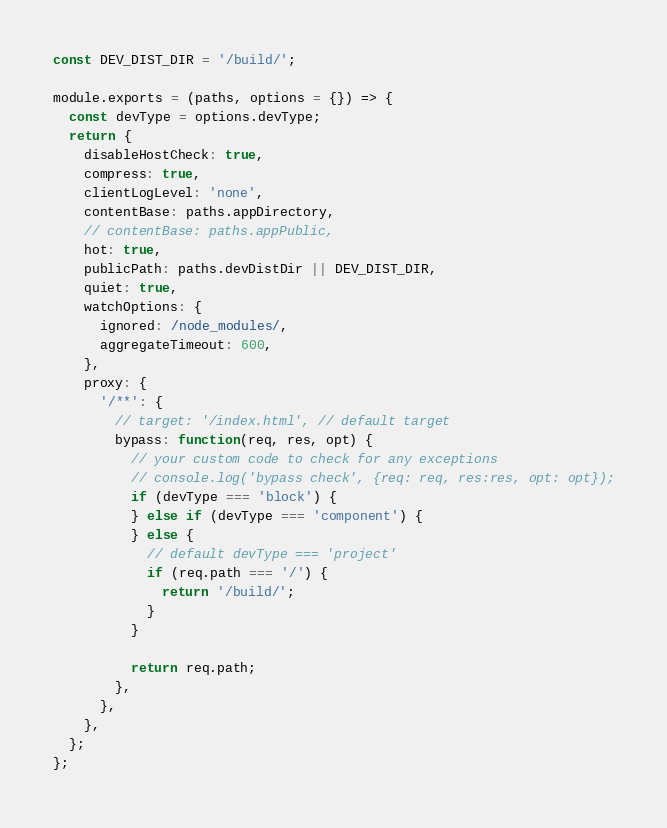<code> <loc_0><loc_0><loc_500><loc_500><_JavaScript_>const DEV_DIST_DIR = '/build/';

module.exports = (paths, options = {}) => {
  const devType = options.devType;
  return {
    disableHostCheck: true,
    compress: true,
    clientLogLevel: 'none',
    contentBase: paths.appDirectory,
    // contentBase: paths.appPublic,
    hot: true,
    publicPath: paths.devDistDir || DEV_DIST_DIR,
    quiet: true,
    watchOptions: {
      ignored: /node_modules/,
      aggregateTimeout: 600,
    },
    proxy: {
      '/**': {
        // target: '/index.html', // default target
        bypass: function(req, res, opt) {
          // your custom code to check for any exceptions
          // console.log('bypass check', {req: req, res:res, opt: opt});
          if (devType === 'block') {
          } else if (devType === 'component') {
          } else {
            // default devType === 'project'
            if (req.path === '/') {
              return '/build/';
            }
          }

          return req.path;
        },
      },
    },
  };
};
</code> 